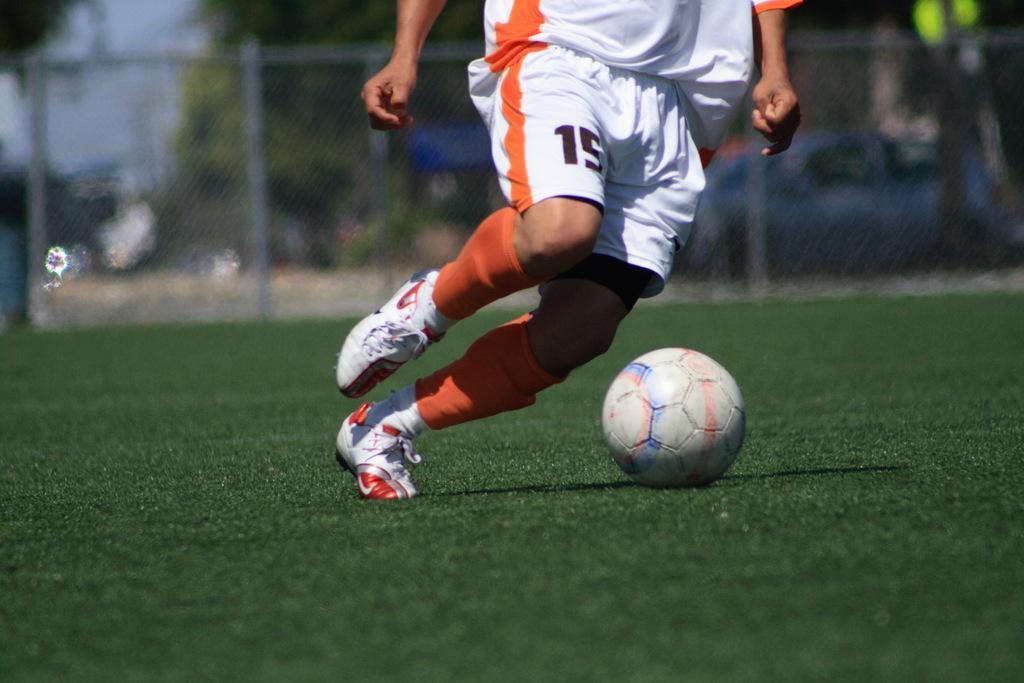Can you describe this image briefly? This is a person running. This looks like a football. I can see a person wear a T-shirt, short, socks and shoes. I think this is the ground. In the background, that looks like a fence. 